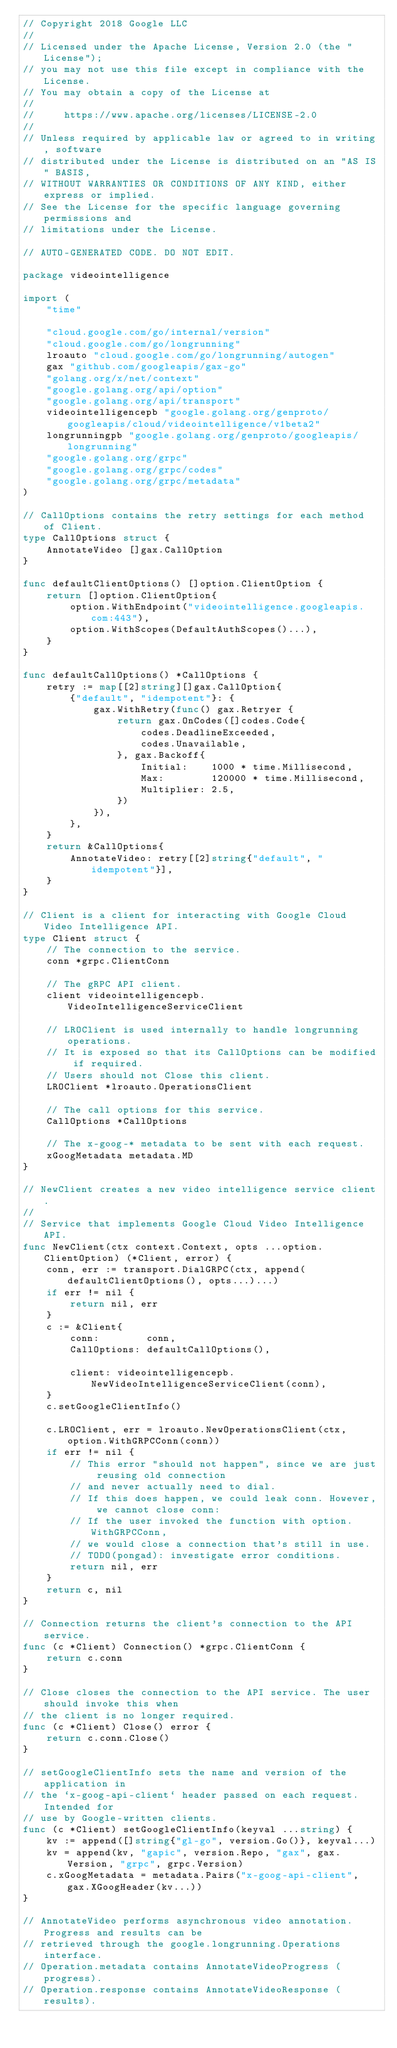Convert code to text. <code><loc_0><loc_0><loc_500><loc_500><_Go_>// Copyright 2018 Google LLC
//
// Licensed under the Apache License, Version 2.0 (the "License");
// you may not use this file except in compliance with the License.
// You may obtain a copy of the License at
//
//     https://www.apache.org/licenses/LICENSE-2.0
//
// Unless required by applicable law or agreed to in writing, software
// distributed under the License is distributed on an "AS IS" BASIS,
// WITHOUT WARRANTIES OR CONDITIONS OF ANY KIND, either express or implied.
// See the License for the specific language governing permissions and
// limitations under the License.

// AUTO-GENERATED CODE. DO NOT EDIT.

package videointelligence

import (
	"time"

	"cloud.google.com/go/internal/version"
	"cloud.google.com/go/longrunning"
	lroauto "cloud.google.com/go/longrunning/autogen"
	gax "github.com/googleapis/gax-go"
	"golang.org/x/net/context"
	"google.golang.org/api/option"
	"google.golang.org/api/transport"
	videointelligencepb "google.golang.org/genproto/googleapis/cloud/videointelligence/v1beta2"
	longrunningpb "google.golang.org/genproto/googleapis/longrunning"
	"google.golang.org/grpc"
	"google.golang.org/grpc/codes"
	"google.golang.org/grpc/metadata"
)

// CallOptions contains the retry settings for each method of Client.
type CallOptions struct {
	AnnotateVideo []gax.CallOption
}

func defaultClientOptions() []option.ClientOption {
	return []option.ClientOption{
		option.WithEndpoint("videointelligence.googleapis.com:443"),
		option.WithScopes(DefaultAuthScopes()...),
	}
}

func defaultCallOptions() *CallOptions {
	retry := map[[2]string][]gax.CallOption{
		{"default", "idempotent"}: {
			gax.WithRetry(func() gax.Retryer {
				return gax.OnCodes([]codes.Code{
					codes.DeadlineExceeded,
					codes.Unavailable,
				}, gax.Backoff{
					Initial:    1000 * time.Millisecond,
					Max:        120000 * time.Millisecond,
					Multiplier: 2.5,
				})
			}),
		},
	}
	return &CallOptions{
		AnnotateVideo: retry[[2]string{"default", "idempotent"}],
	}
}

// Client is a client for interacting with Google Cloud Video Intelligence API.
type Client struct {
	// The connection to the service.
	conn *grpc.ClientConn

	// The gRPC API client.
	client videointelligencepb.VideoIntelligenceServiceClient

	// LROClient is used internally to handle longrunning operations.
	// It is exposed so that its CallOptions can be modified if required.
	// Users should not Close this client.
	LROClient *lroauto.OperationsClient

	// The call options for this service.
	CallOptions *CallOptions

	// The x-goog-* metadata to be sent with each request.
	xGoogMetadata metadata.MD
}

// NewClient creates a new video intelligence service client.
//
// Service that implements Google Cloud Video Intelligence API.
func NewClient(ctx context.Context, opts ...option.ClientOption) (*Client, error) {
	conn, err := transport.DialGRPC(ctx, append(defaultClientOptions(), opts...)...)
	if err != nil {
		return nil, err
	}
	c := &Client{
		conn:        conn,
		CallOptions: defaultCallOptions(),

		client: videointelligencepb.NewVideoIntelligenceServiceClient(conn),
	}
	c.setGoogleClientInfo()

	c.LROClient, err = lroauto.NewOperationsClient(ctx, option.WithGRPCConn(conn))
	if err != nil {
		// This error "should not happen", since we are just reusing old connection
		// and never actually need to dial.
		// If this does happen, we could leak conn. However, we cannot close conn:
		// If the user invoked the function with option.WithGRPCConn,
		// we would close a connection that's still in use.
		// TODO(pongad): investigate error conditions.
		return nil, err
	}
	return c, nil
}

// Connection returns the client's connection to the API service.
func (c *Client) Connection() *grpc.ClientConn {
	return c.conn
}

// Close closes the connection to the API service. The user should invoke this when
// the client is no longer required.
func (c *Client) Close() error {
	return c.conn.Close()
}

// setGoogleClientInfo sets the name and version of the application in
// the `x-goog-api-client` header passed on each request. Intended for
// use by Google-written clients.
func (c *Client) setGoogleClientInfo(keyval ...string) {
	kv := append([]string{"gl-go", version.Go()}, keyval...)
	kv = append(kv, "gapic", version.Repo, "gax", gax.Version, "grpc", grpc.Version)
	c.xGoogMetadata = metadata.Pairs("x-goog-api-client", gax.XGoogHeader(kv...))
}

// AnnotateVideo performs asynchronous video annotation. Progress and results can be
// retrieved through the google.longrunning.Operations interface.
// Operation.metadata contains AnnotateVideoProgress (progress).
// Operation.response contains AnnotateVideoResponse (results).</code> 